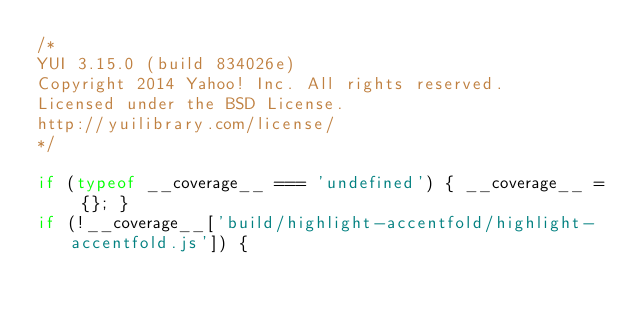<code> <loc_0><loc_0><loc_500><loc_500><_JavaScript_>/*
YUI 3.15.0 (build 834026e)
Copyright 2014 Yahoo! Inc. All rights reserved.
Licensed under the BSD License.
http://yuilibrary.com/license/
*/

if (typeof __coverage__ === 'undefined') { __coverage__ = {}; }
if (!__coverage__['build/highlight-accentfold/highlight-accentfold.js']) {</code> 